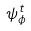Convert formula to latex. <formula><loc_0><loc_0><loc_500><loc_500>\psi _ { \phi } ^ { t }</formula> 